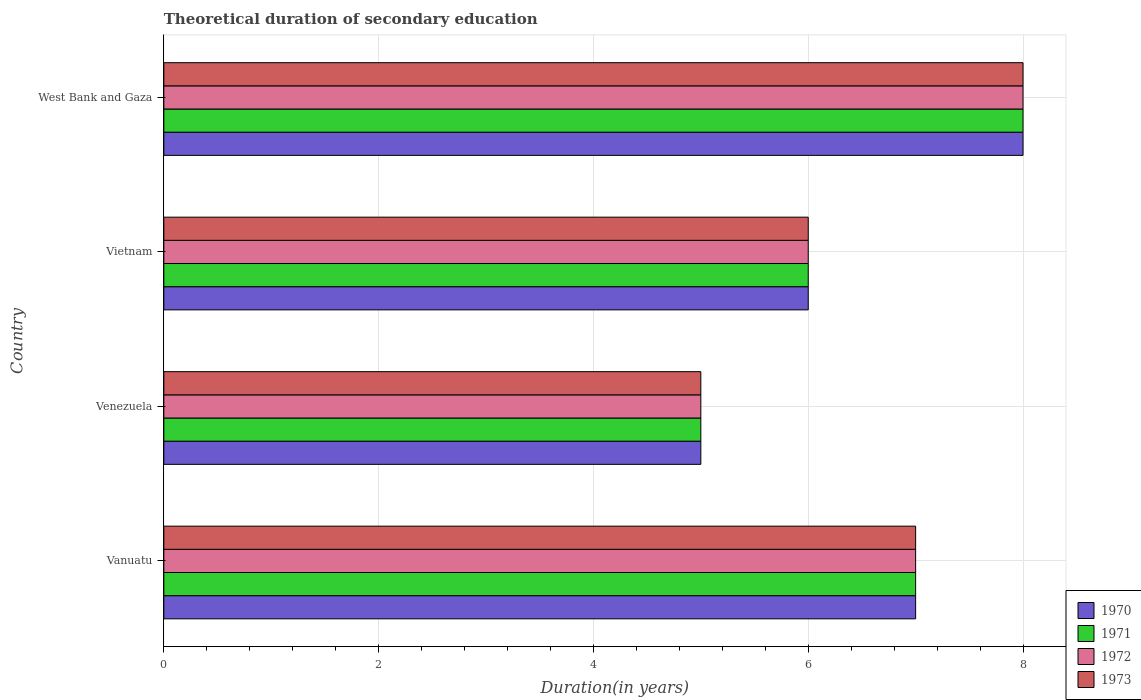How many different coloured bars are there?
Give a very brief answer. 4. Are the number of bars per tick equal to the number of legend labels?
Keep it short and to the point. Yes. How many bars are there on the 4th tick from the bottom?
Provide a succinct answer. 4. What is the label of the 3rd group of bars from the top?
Offer a very short reply. Venezuela. In which country was the total theoretical duration of secondary education in 1971 maximum?
Provide a succinct answer. West Bank and Gaza. In which country was the total theoretical duration of secondary education in 1972 minimum?
Offer a terse response. Venezuela. What is the difference between the total theoretical duration of secondary education in 1973 and total theoretical duration of secondary education in 1971 in Vietnam?
Provide a succinct answer. 0. In how many countries, is the total theoretical duration of secondary education in 1971 greater than 2.8 years?
Offer a very short reply. 4. What is the ratio of the total theoretical duration of secondary education in 1973 in Vietnam to that in West Bank and Gaza?
Give a very brief answer. 0.75. Is the total theoretical duration of secondary education in 1973 in Vanuatu less than that in West Bank and Gaza?
Keep it short and to the point. Yes. Is the difference between the total theoretical duration of secondary education in 1973 in Venezuela and West Bank and Gaza greater than the difference between the total theoretical duration of secondary education in 1971 in Venezuela and West Bank and Gaza?
Offer a terse response. No. In how many countries, is the total theoretical duration of secondary education in 1972 greater than the average total theoretical duration of secondary education in 1972 taken over all countries?
Provide a short and direct response. 2. What does the 1st bar from the top in Vanuatu represents?
Offer a very short reply. 1973. What does the 2nd bar from the bottom in Vietnam represents?
Keep it short and to the point. 1971. Is it the case that in every country, the sum of the total theoretical duration of secondary education in 1970 and total theoretical duration of secondary education in 1973 is greater than the total theoretical duration of secondary education in 1971?
Make the answer very short. Yes. How many bars are there?
Offer a very short reply. 16. Are the values on the major ticks of X-axis written in scientific E-notation?
Keep it short and to the point. No. Does the graph contain any zero values?
Give a very brief answer. No. How many legend labels are there?
Make the answer very short. 4. What is the title of the graph?
Offer a terse response. Theoretical duration of secondary education. Does "1969" appear as one of the legend labels in the graph?
Your response must be concise. No. What is the label or title of the X-axis?
Ensure brevity in your answer.  Duration(in years). What is the label or title of the Y-axis?
Ensure brevity in your answer.  Country. What is the Duration(in years) in 1970 in Vanuatu?
Your answer should be very brief. 7. What is the Duration(in years) of 1971 in Vanuatu?
Your answer should be very brief. 7. What is the Duration(in years) of 1972 in Vanuatu?
Ensure brevity in your answer.  7. What is the Duration(in years) in 1970 in Venezuela?
Offer a terse response. 5. What is the Duration(in years) in 1970 in Vietnam?
Keep it short and to the point. 6. What is the Duration(in years) of 1971 in Vietnam?
Your answer should be compact. 6. What is the Duration(in years) in 1973 in Vietnam?
Your answer should be very brief. 6. What is the Duration(in years) in 1973 in West Bank and Gaza?
Your answer should be compact. 8. Across all countries, what is the maximum Duration(in years) of 1970?
Offer a very short reply. 8. Across all countries, what is the maximum Duration(in years) of 1972?
Make the answer very short. 8. Across all countries, what is the maximum Duration(in years) of 1973?
Your answer should be very brief. 8. Across all countries, what is the minimum Duration(in years) of 1970?
Offer a very short reply. 5. Across all countries, what is the minimum Duration(in years) in 1971?
Make the answer very short. 5. Across all countries, what is the minimum Duration(in years) in 1973?
Your answer should be very brief. 5. What is the total Duration(in years) in 1972 in the graph?
Your answer should be very brief. 26. What is the difference between the Duration(in years) in 1970 in Vanuatu and that in Venezuela?
Offer a terse response. 2. What is the difference between the Duration(in years) of 1972 in Vanuatu and that in Venezuela?
Your response must be concise. 2. What is the difference between the Duration(in years) in 1973 in Vanuatu and that in Venezuela?
Provide a succinct answer. 2. What is the difference between the Duration(in years) in 1970 in Vanuatu and that in Vietnam?
Ensure brevity in your answer.  1. What is the difference between the Duration(in years) of 1971 in Vanuatu and that in Vietnam?
Give a very brief answer. 1. What is the difference between the Duration(in years) of 1972 in Vanuatu and that in Vietnam?
Ensure brevity in your answer.  1. What is the difference between the Duration(in years) in 1973 in Vanuatu and that in Vietnam?
Ensure brevity in your answer.  1. What is the difference between the Duration(in years) in 1971 in Vanuatu and that in West Bank and Gaza?
Ensure brevity in your answer.  -1. What is the difference between the Duration(in years) in 1972 in Vanuatu and that in West Bank and Gaza?
Make the answer very short. -1. What is the difference between the Duration(in years) of 1973 in Vanuatu and that in West Bank and Gaza?
Give a very brief answer. -1. What is the difference between the Duration(in years) in 1970 in Venezuela and that in Vietnam?
Your answer should be very brief. -1. What is the difference between the Duration(in years) of 1971 in Venezuela and that in Vietnam?
Give a very brief answer. -1. What is the difference between the Duration(in years) of 1973 in Venezuela and that in Vietnam?
Provide a succinct answer. -1. What is the difference between the Duration(in years) of 1971 in Venezuela and that in West Bank and Gaza?
Your answer should be compact. -3. What is the difference between the Duration(in years) of 1973 in Venezuela and that in West Bank and Gaza?
Offer a very short reply. -3. What is the difference between the Duration(in years) in 1970 in Vietnam and that in West Bank and Gaza?
Make the answer very short. -2. What is the difference between the Duration(in years) in 1971 in Vietnam and that in West Bank and Gaza?
Provide a short and direct response. -2. What is the difference between the Duration(in years) in 1972 in Vietnam and that in West Bank and Gaza?
Offer a terse response. -2. What is the difference between the Duration(in years) of 1970 in Vanuatu and the Duration(in years) of 1971 in Venezuela?
Provide a succinct answer. 2. What is the difference between the Duration(in years) of 1970 in Vanuatu and the Duration(in years) of 1972 in Venezuela?
Offer a very short reply. 2. What is the difference between the Duration(in years) of 1970 in Vanuatu and the Duration(in years) of 1973 in Venezuela?
Provide a succinct answer. 2. What is the difference between the Duration(in years) of 1971 in Vanuatu and the Duration(in years) of 1972 in Venezuela?
Ensure brevity in your answer.  2. What is the difference between the Duration(in years) of 1972 in Vanuatu and the Duration(in years) of 1973 in Venezuela?
Ensure brevity in your answer.  2. What is the difference between the Duration(in years) in 1970 in Vanuatu and the Duration(in years) in 1971 in Vietnam?
Provide a short and direct response. 1. What is the difference between the Duration(in years) in 1970 in Vanuatu and the Duration(in years) in 1972 in Vietnam?
Keep it short and to the point. 1. What is the difference between the Duration(in years) in 1970 in Vanuatu and the Duration(in years) in 1973 in Vietnam?
Keep it short and to the point. 1. What is the difference between the Duration(in years) in 1972 in Vanuatu and the Duration(in years) in 1973 in Vietnam?
Provide a succinct answer. 1. What is the difference between the Duration(in years) in 1970 in Vanuatu and the Duration(in years) in 1972 in West Bank and Gaza?
Offer a very short reply. -1. What is the difference between the Duration(in years) in 1970 in Vanuatu and the Duration(in years) in 1973 in West Bank and Gaza?
Make the answer very short. -1. What is the difference between the Duration(in years) in 1971 in Vanuatu and the Duration(in years) in 1972 in West Bank and Gaza?
Keep it short and to the point. -1. What is the difference between the Duration(in years) in 1971 in Vanuatu and the Duration(in years) in 1973 in West Bank and Gaza?
Give a very brief answer. -1. What is the difference between the Duration(in years) in 1972 in Vanuatu and the Duration(in years) in 1973 in West Bank and Gaza?
Make the answer very short. -1. What is the difference between the Duration(in years) in 1970 in Venezuela and the Duration(in years) in 1971 in Vietnam?
Keep it short and to the point. -1. What is the difference between the Duration(in years) of 1970 in Venezuela and the Duration(in years) of 1972 in Vietnam?
Provide a succinct answer. -1. What is the difference between the Duration(in years) in 1971 in Venezuela and the Duration(in years) in 1972 in Vietnam?
Your response must be concise. -1. What is the difference between the Duration(in years) in 1971 in Venezuela and the Duration(in years) in 1973 in Vietnam?
Your answer should be compact. -1. What is the difference between the Duration(in years) of 1970 in Venezuela and the Duration(in years) of 1971 in West Bank and Gaza?
Your answer should be very brief. -3. What is the difference between the Duration(in years) in 1970 in Venezuela and the Duration(in years) in 1972 in West Bank and Gaza?
Your answer should be compact. -3. What is the difference between the Duration(in years) in 1970 in Vietnam and the Duration(in years) in 1972 in West Bank and Gaza?
Provide a succinct answer. -2. What is the difference between the Duration(in years) of 1970 in Vietnam and the Duration(in years) of 1973 in West Bank and Gaza?
Keep it short and to the point. -2. What is the difference between the Duration(in years) of 1971 in Vietnam and the Duration(in years) of 1973 in West Bank and Gaza?
Offer a terse response. -2. What is the difference between the Duration(in years) of 1972 in Vietnam and the Duration(in years) of 1973 in West Bank and Gaza?
Your response must be concise. -2. What is the difference between the Duration(in years) in 1970 and Duration(in years) in 1971 in Vanuatu?
Your answer should be very brief. 0. What is the difference between the Duration(in years) of 1970 and Duration(in years) of 1972 in Vanuatu?
Keep it short and to the point. 0. What is the difference between the Duration(in years) of 1970 and Duration(in years) of 1971 in Venezuela?
Offer a very short reply. 0. What is the difference between the Duration(in years) of 1970 and Duration(in years) of 1973 in Venezuela?
Provide a short and direct response. 0. What is the difference between the Duration(in years) in 1972 and Duration(in years) in 1973 in Venezuela?
Provide a short and direct response. 0. What is the difference between the Duration(in years) of 1970 and Duration(in years) of 1972 in Vietnam?
Provide a short and direct response. 0. What is the difference between the Duration(in years) in 1970 and Duration(in years) in 1973 in Vietnam?
Your answer should be very brief. 0. What is the difference between the Duration(in years) of 1971 and Duration(in years) of 1973 in Vietnam?
Keep it short and to the point. 0. What is the difference between the Duration(in years) of 1970 and Duration(in years) of 1972 in West Bank and Gaza?
Your answer should be very brief. 0. What is the difference between the Duration(in years) in 1972 and Duration(in years) in 1973 in West Bank and Gaza?
Your answer should be compact. 0. What is the ratio of the Duration(in years) of 1970 in Vanuatu to that in Venezuela?
Your answer should be compact. 1.4. What is the ratio of the Duration(in years) in 1972 in Vanuatu to that in Venezuela?
Provide a short and direct response. 1.4. What is the ratio of the Duration(in years) in 1973 in Vanuatu to that in Venezuela?
Make the answer very short. 1.4. What is the ratio of the Duration(in years) of 1970 in Vanuatu to that in Vietnam?
Your answer should be compact. 1.17. What is the ratio of the Duration(in years) of 1971 in Vanuatu to that in Vietnam?
Your response must be concise. 1.17. What is the ratio of the Duration(in years) in 1972 in Vanuatu to that in Vietnam?
Make the answer very short. 1.17. What is the ratio of the Duration(in years) of 1973 in Vanuatu to that in Vietnam?
Your answer should be compact. 1.17. What is the ratio of the Duration(in years) of 1970 in Vanuatu to that in West Bank and Gaza?
Keep it short and to the point. 0.88. What is the ratio of the Duration(in years) in 1972 in Vanuatu to that in West Bank and Gaza?
Your answer should be compact. 0.88. What is the ratio of the Duration(in years) of 1970 in Venezuela to that in Vietnam?
Keep it short and to the point. 0.83. What is the ratio of the Duration(in years) of 1972 in Venezuela to that in Vietnam?
Your answer should be very brief. 0.83. What is the ratio of the Duration(in years) in 1970 in Venezuela to that in West Bank and Gaza?
Your response must be concise. 0.62. What is the ratio of the Duration(in years) in 1972 in Vietnam to that in West Bank and Gaza?
Provide a short and direct response. 0.75. What is the ratio of the Duration(in years) of 1973 in Vietnam to that in West Bank and Gaza?
Ensure brevity in your answer.  0.75. What is the difference between the highest and the second highest Duration(in years) in 1970?
Your answer should be very brief. 1. What is the difference between the highest and the second highest Duration(in years) in 1971?
Your answer should be very brief. 1. What is the difference between the highest and the lowest Duration(in years) in 1970?
Ensure brevity in your answer.  3. What is the difference between the highest and the lowest Duration(in years) in 1971?
Your response must be concise. 3. What is the difference between the highest and the lowest Duration(in years) in 1972?
Your answer should be compact. 3. What is the difference between the highest and the lowest Duration(in years) of 1973?
Your answer should be very brief. 3. 